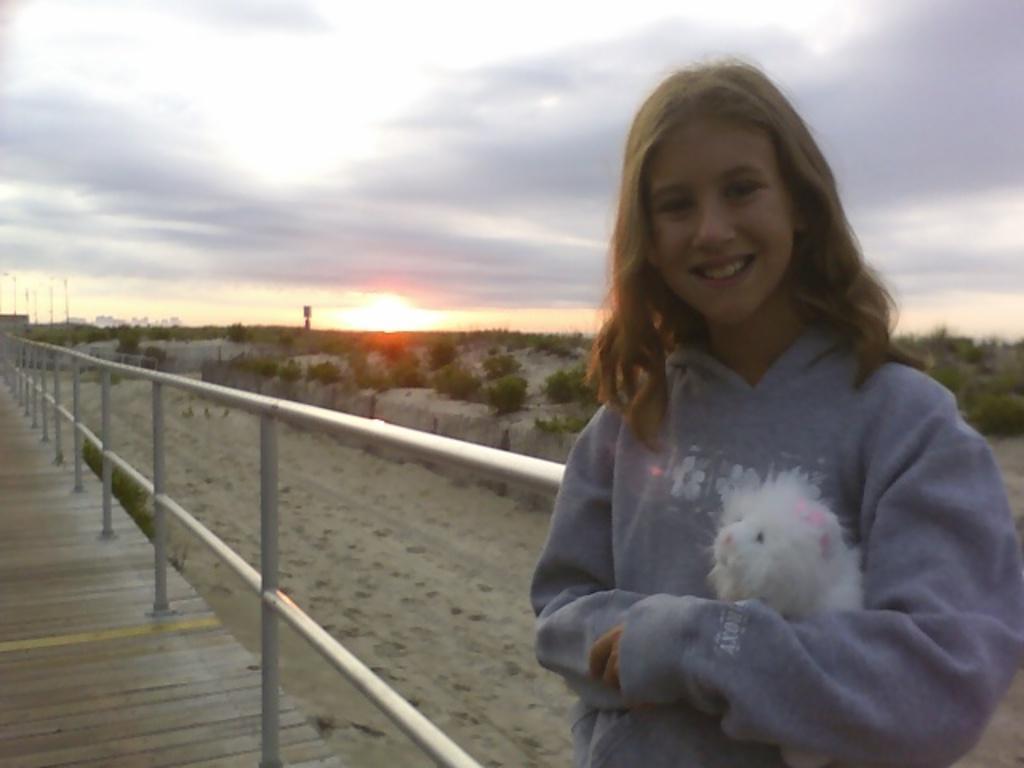Describe this image in one or two sentences. In this image there is a girl standing with a smile on her face and she is holding an object, behind her there is a railing. In the background there are trees and a sky. 